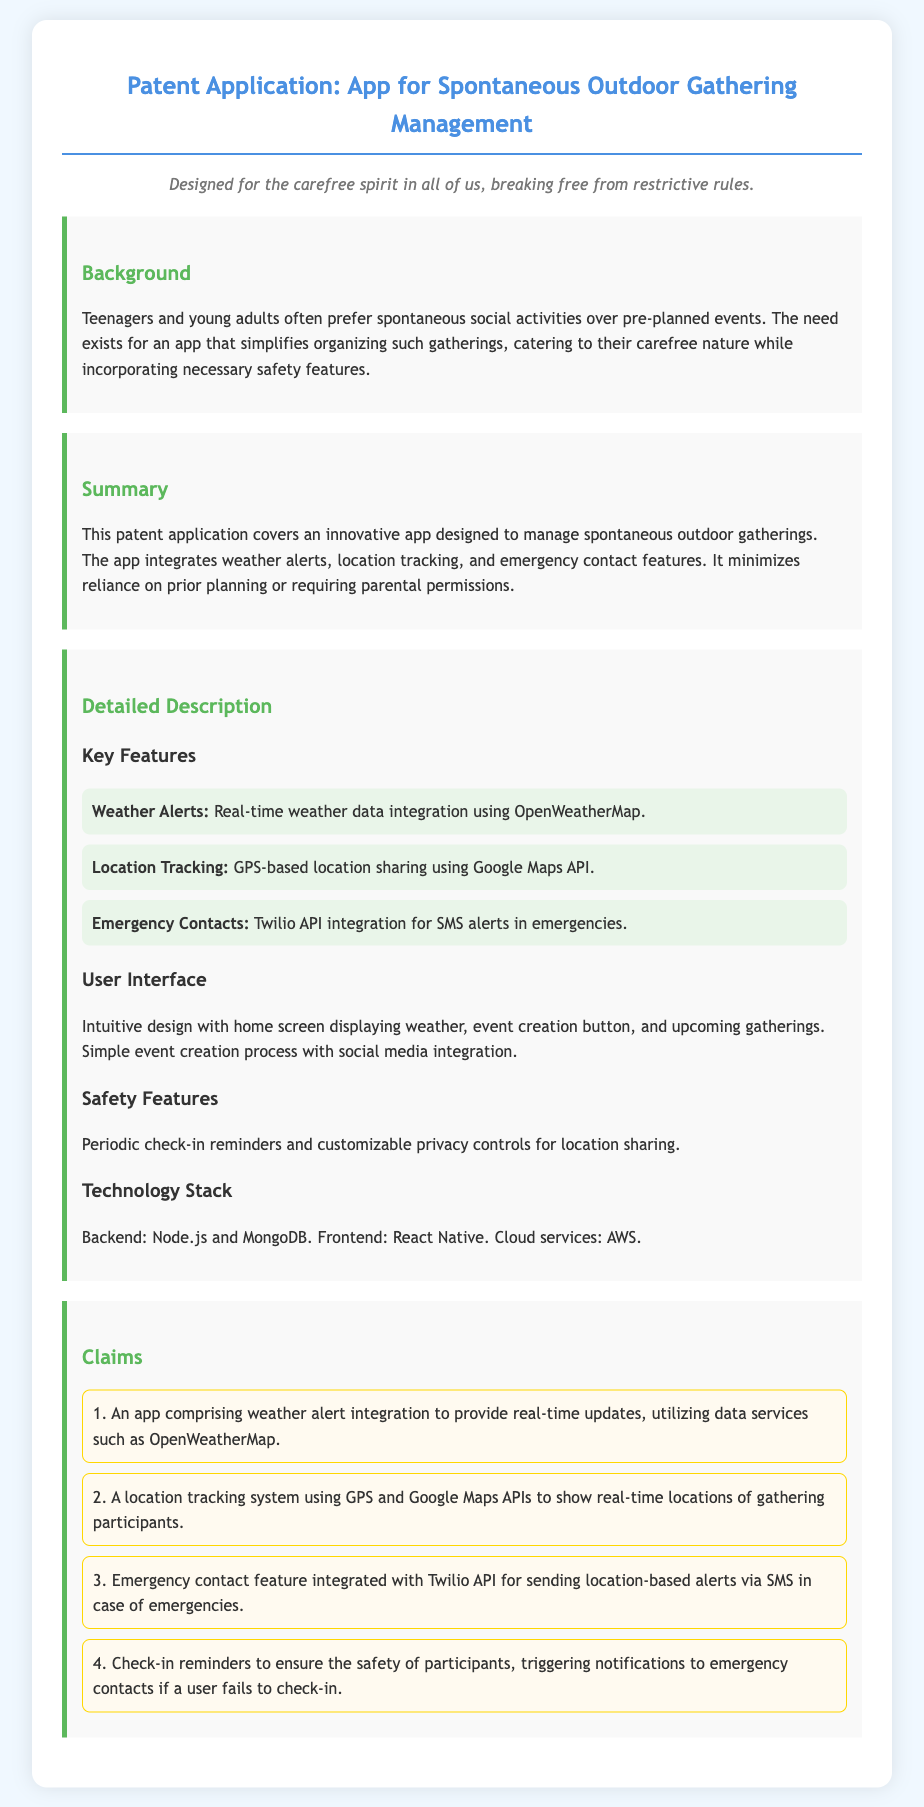what is the title of the patent application? The title of the patent application is stated at the top of the document.
Answer: App for Spontaneous Outdoor Gathering Management what is the purpose of the app? The purpose of the app is outlined in the Summary section, highlighting its role in managing spontaneous outdoor gatherings.
Answer: To manage spontaneous outdoor gatherings how many key features are listed in the document? The number of key features is found in the Detailed Description section under Key Features.
Answer: Three what technology is used for the backend of the app? The backend technology is provided in the Technology Stack section of the document.
Answer: Node.js and MongoDB what is the main user demographic targeted by this app? The document specifies the demographic in the Background section, focusing on the app's users.
Answer: Teenagers and young adults what is the function of the Twilio API in the app? The role of the Twilio API is explained in the Emergency Contacts feature of the Detailed Description.
Answer: Sending location-based alerts via SMS how does the app ensure safety for participants? Safety measures are discussed in the Safety Features section of the Detailed Description.
Answer: Check-in reminders and customizable privacy controls what type of user interface is described? The user interface specifics are mentioned in the User Interface section of the document.
Answer: Intuitive design what is the weather service integrated into the app? The weather service used in the app is found in the Key Features section.
Answer: OpenWeatherMap 